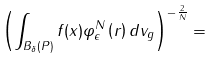<formula> <loc_0><loc_0><loc_500><loc_500>\left ( \int _ { B _ { \delta } \left ( P \right ) } f ( x ) \varphi _ { \epsilon } ^ { N } \left ( r \right ) d v _ { g } \right ) ^ { - \frac { 2 } { N } } =</formula> 